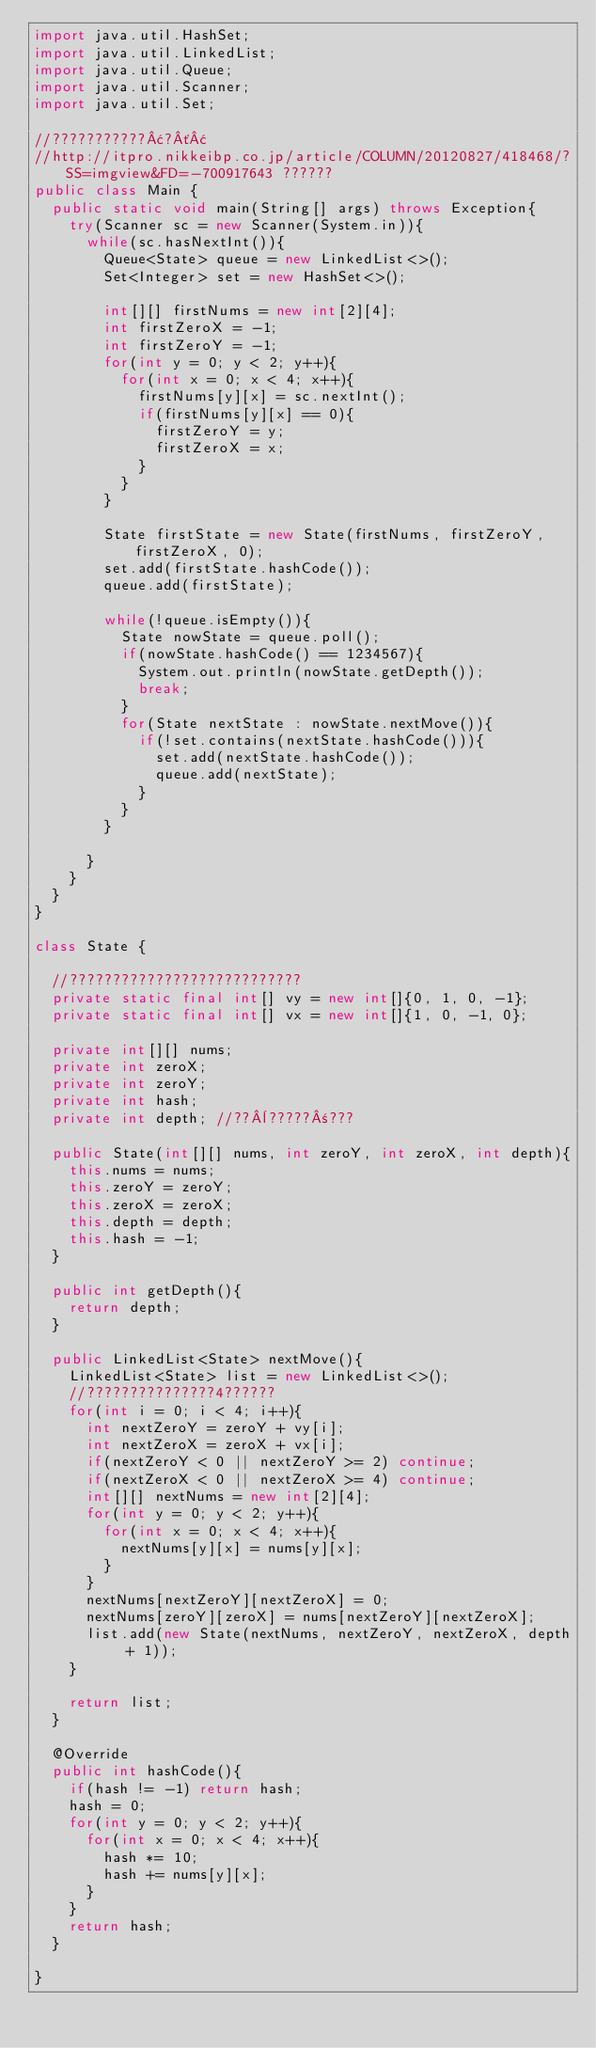<code> <loc_0><loc_0><loc_500><loc_500><_Java_>import java.util.HashSet;
import java.util.LinkedList;
import java.util.Queue;
import java.util.Scanner;
import java.util.Set;

//???????????¢?´¢
//http://itpro.nikkeibp.co.jp/article/COLUMN/20120827/418468/?SS=imgview&FD=-700917643 ??????
public class Main {
	public static void main(String[] args) throws Exception{
		try(Scanner sc = new Scanner(System.in)){
			while(sc.hasNextInt()){
				Queue<State> queue = new LinkedList<>();
				Set<Integer> set = new HashSet<>();

				int[][] firstNums = new int[2][4];
				int firstZeroX = -1;
				int firstZeroY = -1;
				for(int y = 0; y < 2; y++){
					for(int x = 0; x < 4; x++){
						firstNums[y][x] = sc.nextInt();
						if(firstNums[y][x] == 0){
							firstZeroY = y;
							firstZeroX = x;
						}
					}
				}

				State firstState = new State(firstNums, firstZeroY, firstZeroX, 0);
				set.add(firstState.hashCode());
				queue.add(firstState);

				while(!queue.isEmpty()){
					State nowState = queue.poll();
					if(nowState.hashCode() == 1234567){
						System.out.println(nowState.getDepth());
						break;
					}
					for(State nextState : nowState.nextMove()){
						if(!set.contains(nextState.hashCode())){
							set.add(nextState.hashCode());
							queue.add(nextState);
						}
					}
				}

			}
		}
	}
}

class State {

	//???????????????????????????
	private static final int[] vy = new int[]{0, 1, 0, -1};
	private static final int[] vx = new int[]{1, 0, -1, 0};

	private int[][] nums;
	private int zeroX;
	private int zeroY;
	private int hash;
	private int depth; //??¨?????±???

	public State(int[][] nums, int zeroY, int zeroX, int depth){
		this.nums = nums;
		this.zeroY = zeroY;
		this.zeroX = zeroX;
		this.depth = depth;
		this.hash = -1;
	}

	public int getDepth(){
		return depth;
	}

	public LinkedList<State> nextMove(){
		LinkedList<State> list = new LinkedList<>();
		//???????????????4??????
		for(int i = 0; i < 4; i++){
			int nextZeroY = zeroY + vy[i];
			int nextZeroX = zeroX + vx[i];
			if(nextZeroY < 0 || nextZeroY >= 2) continue;
			if(nextZeroX < 0 || nextZeroX >= 4) continue;
			int[][] nextNums = new int[2][4];
			for(int y = 0; y < 2; y++){
				for(int x = 0; x < 4; x++){
					nextNums[y][x] = nums[y][x];
				}
			}
			nextNums[nextZeroY][nextZeroX] = 0;
			nextNums[zeroY][zeroX] = nums[nextZeroY][nextZeroX];
			list.add(new State(nextNums, nextZeroY, nextZeroX, depth + 1));
		}

		return list;
	}

	@Override
	public int hashCode(){
		if(hash != -1) return hash;
		hash = 0;
		for(int y = 0; y < 2; y++){
			for(int x = 0; x < 4; x++){
				hash *= 10;
				hash += nums[y][x];
			}
		}
		return hash;
	}

}</code> 